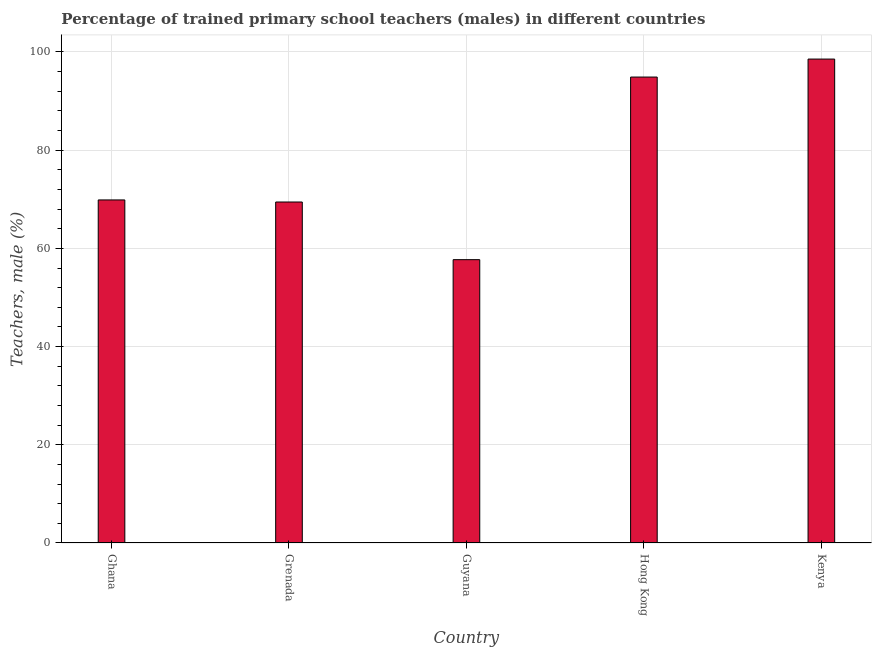Does the graph contain any zero values?
Ensure brevity in your answer.  No. Does the graph contain grids?
Offer a very short reply. Yes. What is the title of the graph?
Give a very brief answer. Percentage of trained primary school teachers (males) in different countries. What is the label or title of the X-axis?
Your response must be concise. Country. What is the label or title of the Y-axis?
Make the answer very short. Teachers, male (%). What is the percentage of trained male teachers in Ghana?
Your response must be concise. 69.87. Across all countries, what is the maximum percentage of trained male teachers?
Offer a very short reply. 98.56. Across all countries, what is the minimum percentage of trained male teachers?
Your answer should be compact. 57.71. In which country was the percentage of trained male teachers maximum?
Your response must be concise. Kenya. In which country was the percentage of trained male teachers minimum?
Provide a short and direct response. Guyana. What is the sum of the percentage of trained male teachers?
Give a very brief answer. 390.48. What is the difference between the percentage of trained male teachers in Grenada and Kenya?
Ensure brevity in your answer.  -29.11. What is the average percentage of trained male teachers per country?
Provide a succinct answer. 78.1. What is the median percentage of trained male teachers?
Give a very brief answer. 69.87. What is the ratio of the percentage of trained male teachers in Ghana to that in Kenya?
Offer a very short reply. 0.71. Is the percentage of trained male teachers in Guyana less than that in Kenya?
Your answer should be very brief. Yes. What is the difference between the highest and the second highest percentage of trained male teachers?
Your answer should be compact. 3.66. What is the difference between the highest and the lowest percentage of trained male teachers?
Make the answer very short. 40.85. Are all the bars in the graph horizontal?
Your response must be concise. No. What is the difference between two consecutive major ticks on the Y-axis?
Offer a very short reply. 20. What is the Teachers, male (%) of Ghana?
Give a very brief answer. 69.87. What is the Teachers, male (%) in Grenada?
Offer a very short reply. 69.45. What is the Teachers, male (%) in Guyana?
Make the answer very short. 57.71. What is the Teachers, male (%) of Hong Kong?
Provide a succinct answer. 94.9. What is the Teachers, male (%) in Kenya?
Offer a terse response. 98.56. What is the difference between the Teachers, male (%) in Ghana and Grenada?
Your answer should be compact. 0.42. What is the difference between the Teachers, male (%) in Ghana and Guyana?
Offer a very short reply. 12.16. What is the difference between the Teachers, male (%) in Ghana and Hong Kong?
Make the answer very short. -25.03. What is the difference between the Teachers, male (%) in Ghana and Kenya?
Your answer should be compact. -28.69. What is the difference between the Teachers, male (%) in Grenada and Guyana?
Ensure brevity in your answer.  11.74. What is the difference between the Teachers, male (%) in Grenada and Hong Kong?
Make the answer very short. -25.45. What is the difference between the Teachers, male (%) in Grenada and Kenya?
Offer a very short reply. -29.11. What is the difference between the Teachers, male (%) in Guyana and Hong Kong?
Provide a succinct answer. -37.19. What is the difference between the Teachers, male (%) in Guyana and Kenya?
Ensure brevity in your answer.  -40.85. What is the difference between the Teachers, male (%) in Hong Kong and Kenya?
Make the answer very short. -3.66. What is the ratio of the Teachers, male (%) in Ghana to that in Grenada?
Provide a short and direct response. 1.01. What is the ratio of the Teachers, male (%) in Ghana to that in Guyana?
Offer a terse response. 1.21. What is the ratio of the Teachers, male (%) in Ghana to that in Hong Kong?
Your answer should be very brief. 0.74. What is the ratio of the Teachers, male (%) in Ghana to that in Kenya?
Your answer should be compact. 0.71. What is the ratio of the Teachers, male (%) in Grenada to that in Guyana?
Keep it short and to the point. 1.2. What is the ratio of the Teachers, male (%) in Grenada to that in Hong Kong?
Offer a very short reply. 0.73. What is the ratio of the Teachers, male (%) in Grenada to that in Kenya?
Provide a succinct answer. 0.7. What is the ratio of the Teachers, male (%) in Guyana to that in Hong Kong?
Give a very brief answer. 0.61. What is the ratio of the Teachers, male (%) in Guyana to that in Kenya?
Provide a succinct answer. 0.58. 